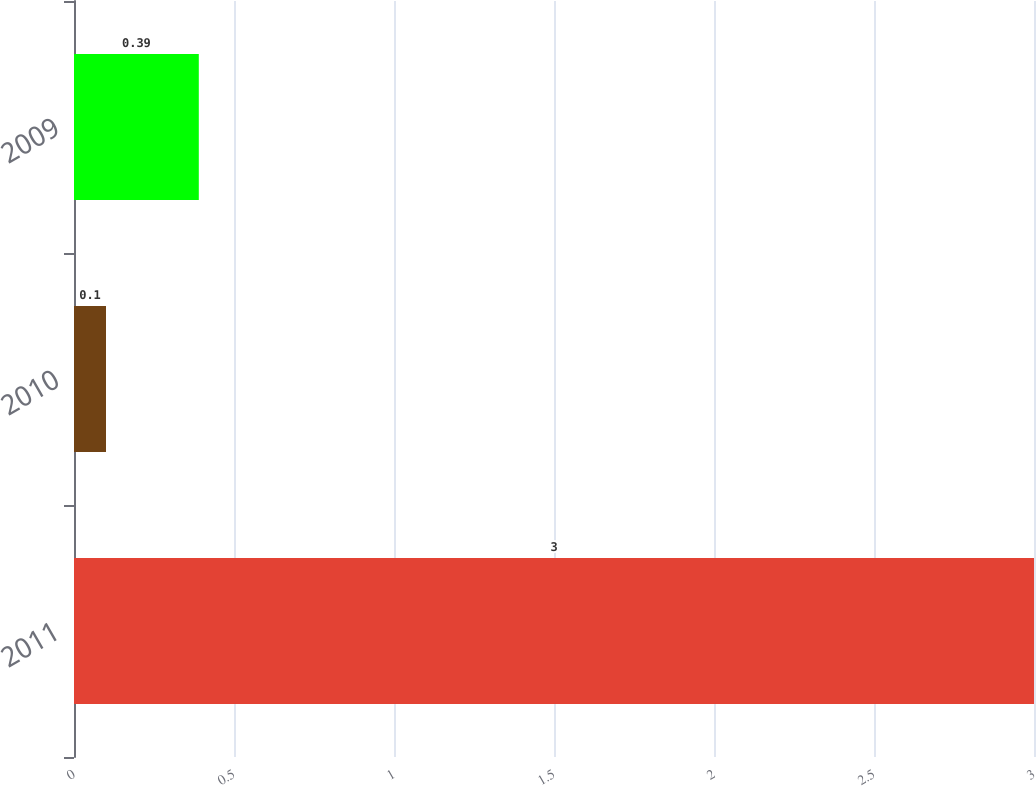<chart> <loc_0><loc_0><loc_500><loc_500><bar_chart><fcel>2011<fcel>2010<fcel>2009<nl><fcel>3<fcel>0.1<fcel>0.39<nl></chart> 